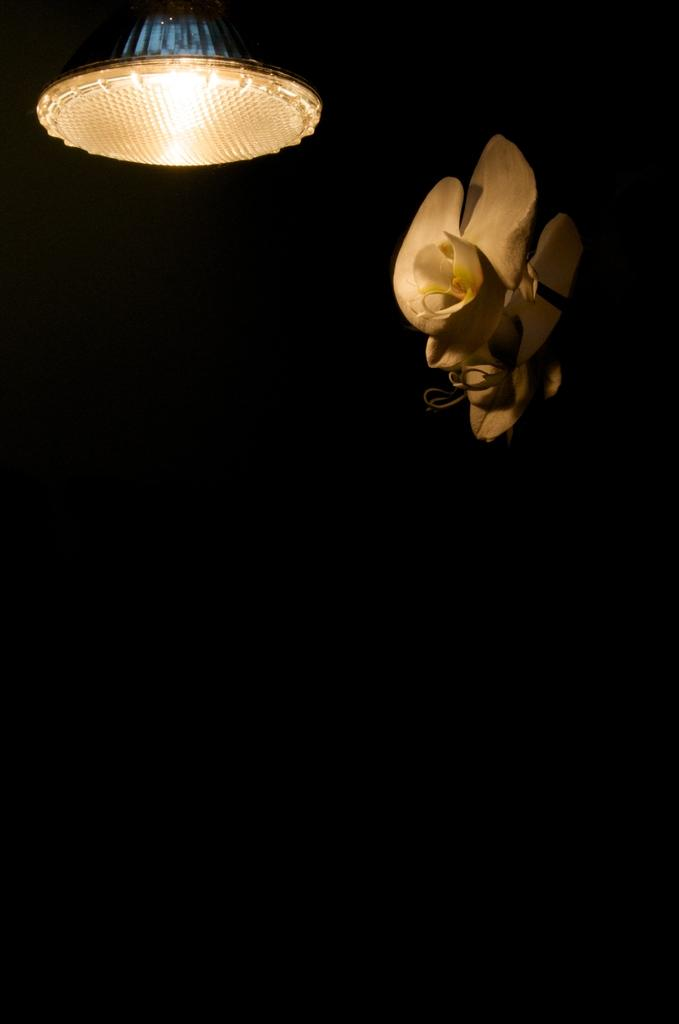What can be seen on the right side of the image? There is a white object on the right side of the image. What is located on the left side of the image? There is a light on the left side of the image. What color is the background of the image? The background of the image is black. Can you tell me how many yaks are present in the image? There are no yaks present in the image; it only features a white object and a light. What type of cork is used to hold the white object in place in the image? There is no cork visible in the image, and the white object's position is not determined by a cork. 